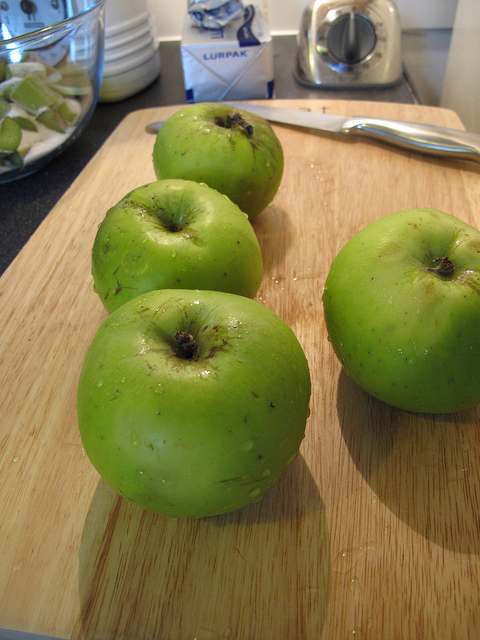Extract all visible text content from this image. LURPAK 